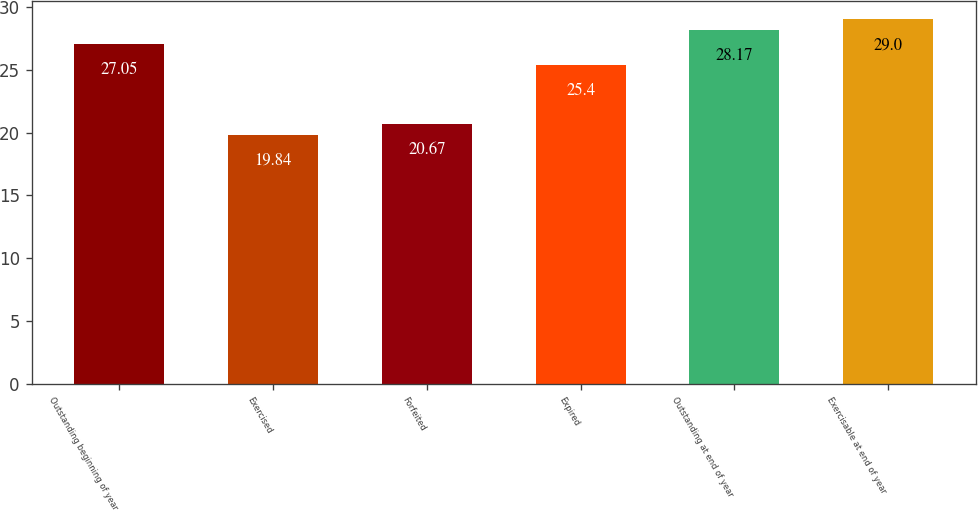Convert chart to OTSL. <chart><loc_0><loc_0><loc_500><loc_500><bar_chart><fcel>Outstanding beginning of year<fcel>Exercised<fcel>Forfeited<fcel>Expired<fcel>Outstanding at end of year<fcel>Exercisable at end of year<nl><fcel>27.05<fcel>19.84<fcel>20.67<fcel>25.4<fcel>28.17<fcel>29<nl></chart> 